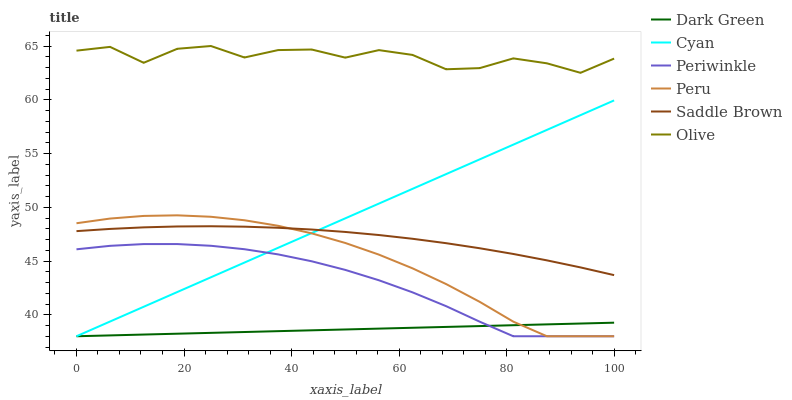Does Dark Green have the minimum area under the curve?
Answer yes or no. Yes. Does Olive have the maximum area under the curve?
Answer yes or no. Yes. Does Peru have the minimum area under the curve?
Answer yes or no. No. Does Peru have the maximum area under the curve?
Answer yes or no. No. Is Dark Green the smoothest?
Answer yes or no. Yes. Is Olive the roughest?
Answer yes or no. Yes. Is Peru the smoothest?
Answer yes or no. No. Is Peru the roughest?
Answer yes or no. No. Does Periwinkle have the lowest value?
Answer yes or no. Yes. Does Olive have the lowest value?
Answer yes or no. No. Does Olive have the highest value?
Answer yes or no. Yes. Does Peru have the highest value?
Answer yes or no. No. Is Periwinkle less than Saddle Brown?
Answer yes or no. Yes. Is Olive greater than Saddle Brown?
Answer yes or no. Yes. Does Periwinkle intersect Cyan?
Answer yes or no. Yes. Is Periwinkle less than Cyan?
Answer yes or no. No. Is Periwinkle greater than Cyan?
Answer yes or no. No. Does Periwinkle intersect Saddle Brown?
Answer yes or no. No. 